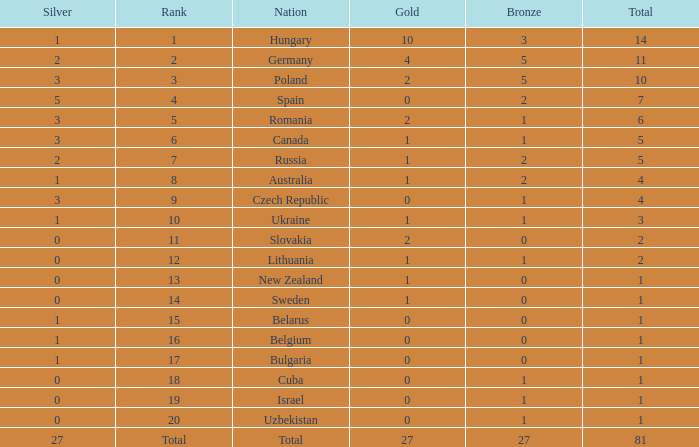Would you mind parsing the complete table? {'header': ['Silver', 'Rank', 'Nation', 'Gold', 'Bronze', 'Total'], 'rows': [['1', '1', 'Hungary', '10', '3', '14'], ['2', '2', 'Germany', '4', '5', '11'], ['3', '3', 'Poland', '2', '5', '10'], ['5', '4', 'Spain', '0', '2', '7'], ['3', '5', 'Romania', '2', '1', '6'], ['3', '6', 'Canada', '1', '1', '5'], ['2', '7', 'Russia', '1', '2', '5'], ['1', '8', 'Australia', '1', '2', '4'], ['3', '9', 'Czech Republic', '0', '1', '4'], ['1', '10', 'Ukraine', '1', '1', '3'], ['0', '11', 'Slovakia', '2', '0', '2'], ['0', '12', 'Lithuania', '1', '1', '2'], ['0', '13', 'New Zealand', '1', '0', '1'], ['0', '14', 'Sweden', '1', '0', '1'], ['1', '15', 'Belarus', '0', '0', '1'], ['1', '16', 'Belgium', '0', '0', '1'], ['1', '17', 'Bulgaria', '0', '0', '1'], ['0', '18', 'Cuba', '0', '1', '1'], ['0', '19', 'Israel', '0', '1', '1'], ['0', '20', 'Uzbekistan', '0', '1', '1'], ['27', 'Total', 'Total', '27', '27', '81']]} How much Silver has a Rank of 1, and a Bronze smaller than 3? None. 